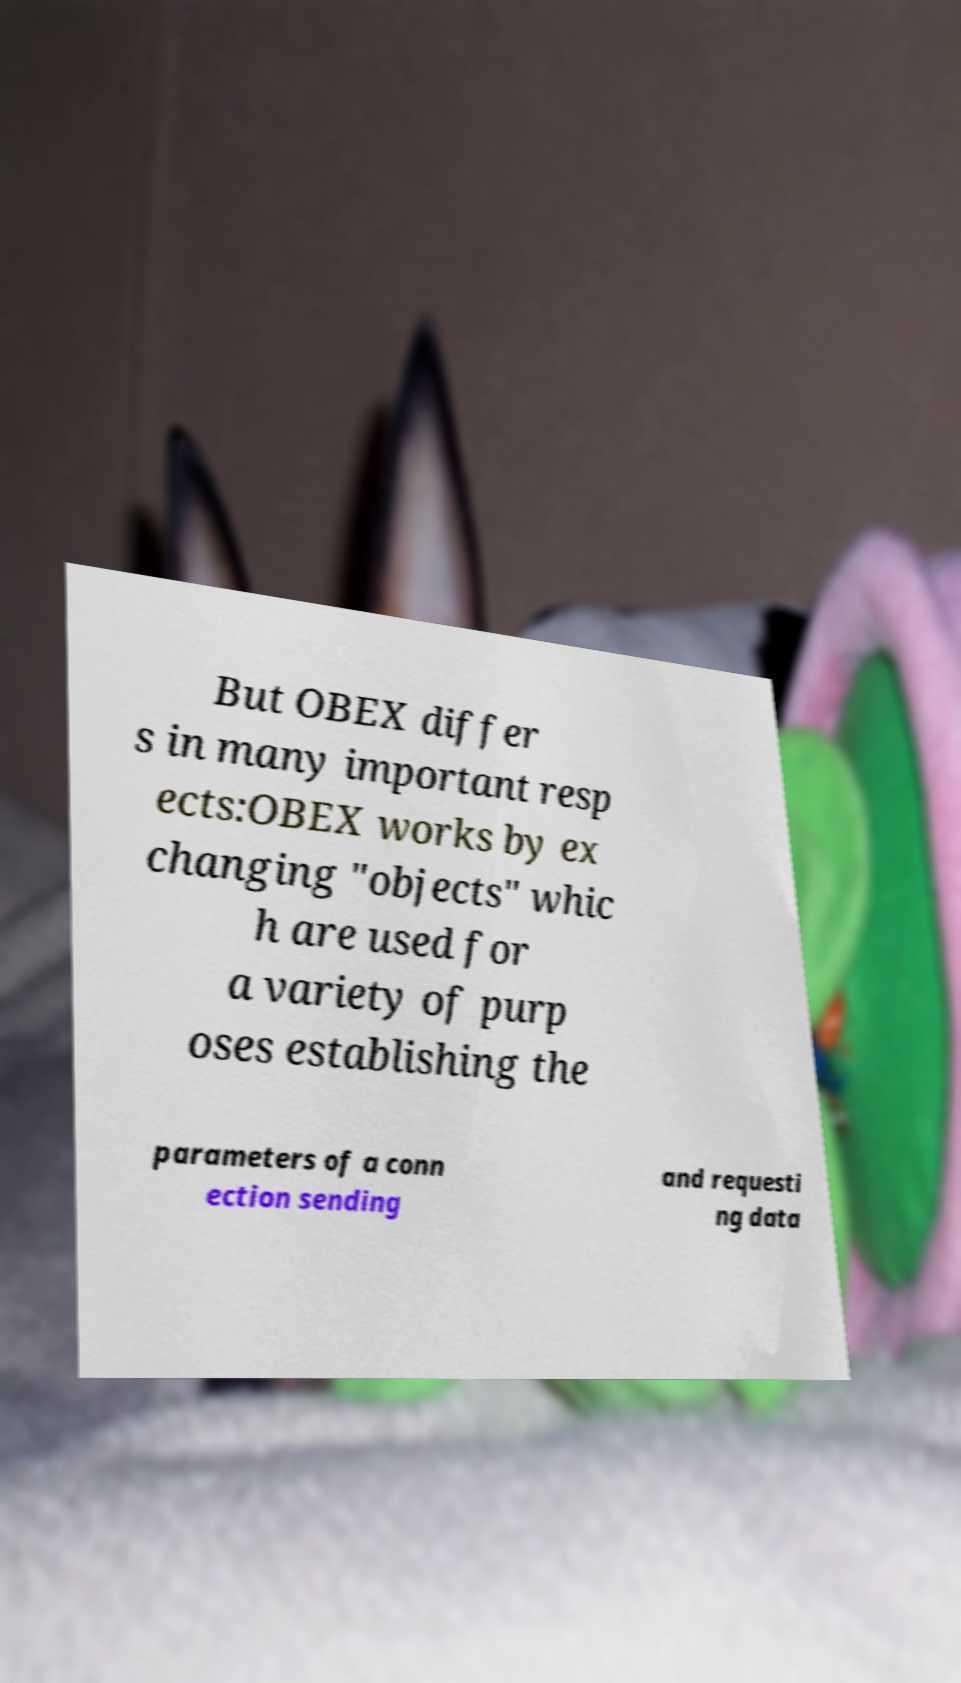I need the written content from this picture converted into text. Can you do that? But OBEX differ s in many important resp ects:OBEX works by ex changing "objects" whic h are used for a variety of purp oses establishing the parameters of a conn ection sending and requesti ng data 